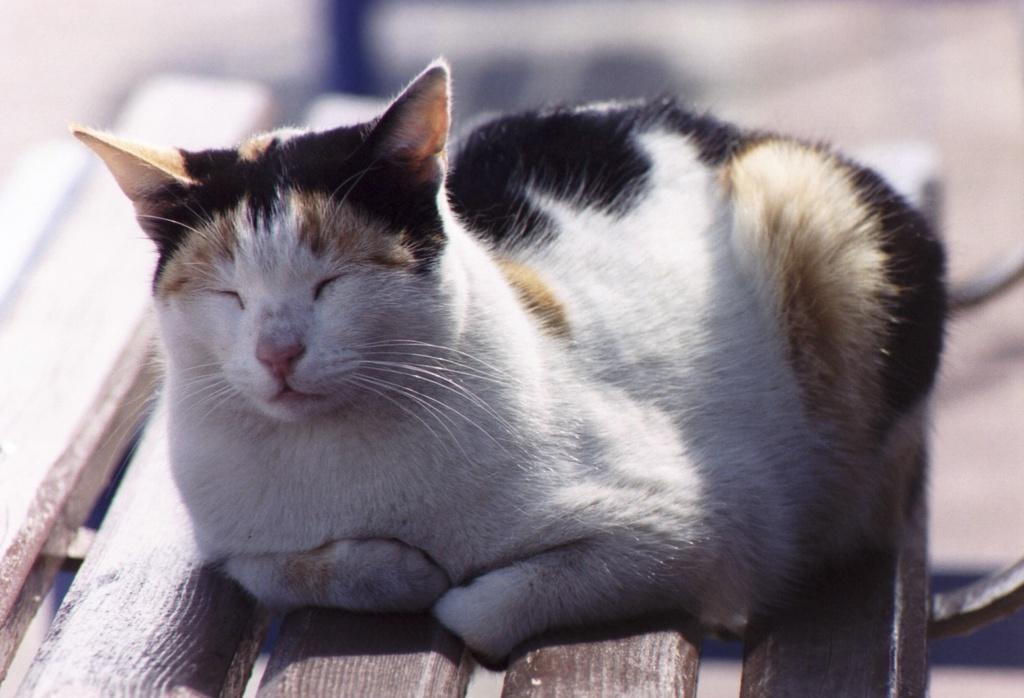What type of animal is in the image? There is a cat in the image. Where is the cat located in the image? The cat is in the center of the image. What is the cat sitting on in the image? The cat is on a bench. What type of hair is visible on the cat in the image? There is no mention of the cat's hair in the provided facts, so it cannot be determined from the image. 